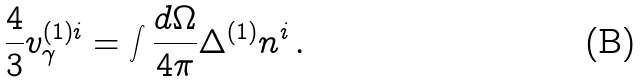Convert formula to latex. <formula><loc_0><loc_0><loc_500><loc_500>\frac { 4 } { 3 } v ^ { ( 1 ) i } _ { \gamma } = \int \frac { d \Omega } { 4 \pi } \Delta ^ { ( 1 ) } n ^ { i } \, .</formula> 